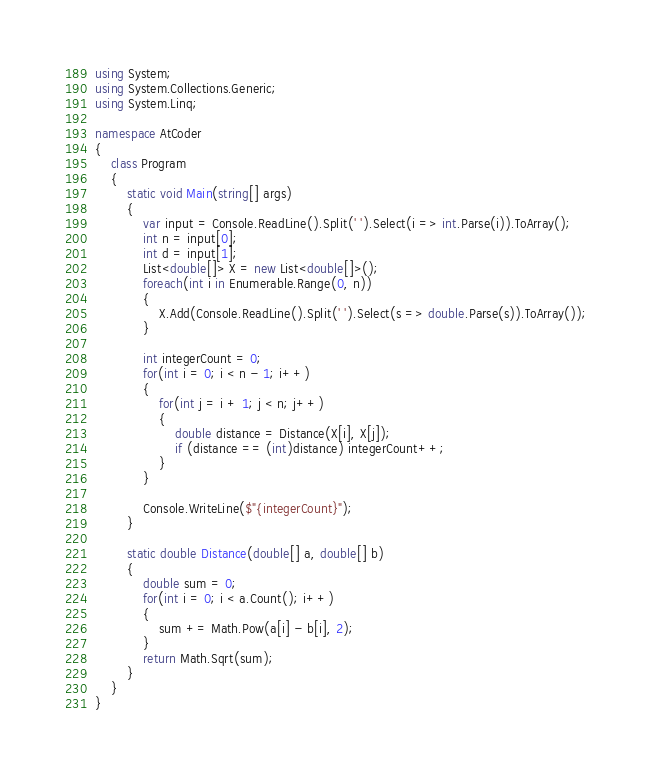Convert code to text. <code><loc_0><loc_0><loc_500><loc_500><_C#_>using System;
using System.Collections.Generic;
using System.Linq;

namespace AtCoder
{
    class Program
    {
        static void Main(string[] args)
        {
            var input = Console.ReadLine().Split(' ').Select(i => int.Parse(i)).ToArray();
            int n = input[0];
            int d = input[1];
            List<double[]> X = new List<double[]>();
            foreach(int i in Enumerable.Range(0, n))
            {
                X.Add(Console.ReadLine().Split(' ').Select(s => double.Parse(s)).ToArray());
            }

            int integerCount = 0;
            for(int i = 0; i < n - 1; i++)
            {
                for(int j = i + 1; j < n; j++)
                {
                    double distance = Distance(X[i], X[j]);
                    if (distance == (int)distance) integerCount++;
                }
            }

            Console.WriteLine($"{integerCount}");
        }

        static double Distance(double[] a, double[] b)
        {
            double sum = 0;
            for(int i = 0; i < a.Count(); i++)
            {
                sum += Math.Pow(a[i] - b[i], 2);
            }
            return Math.Sqrt(sum);
        }
    }
}
</code> 